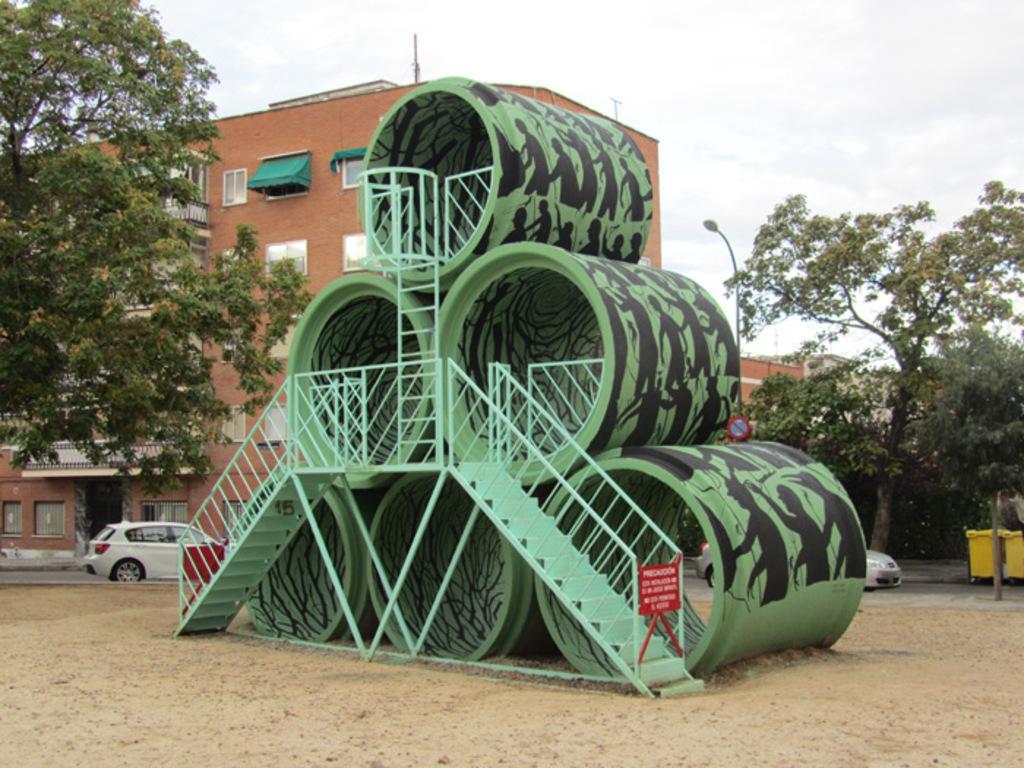Describe this image in one or two sentences. In this image we can see an architecture which is in a pyramid shape with stairs. There is a building, cars, poles and trees in the background of the image. The sky is covered with the clouds. 